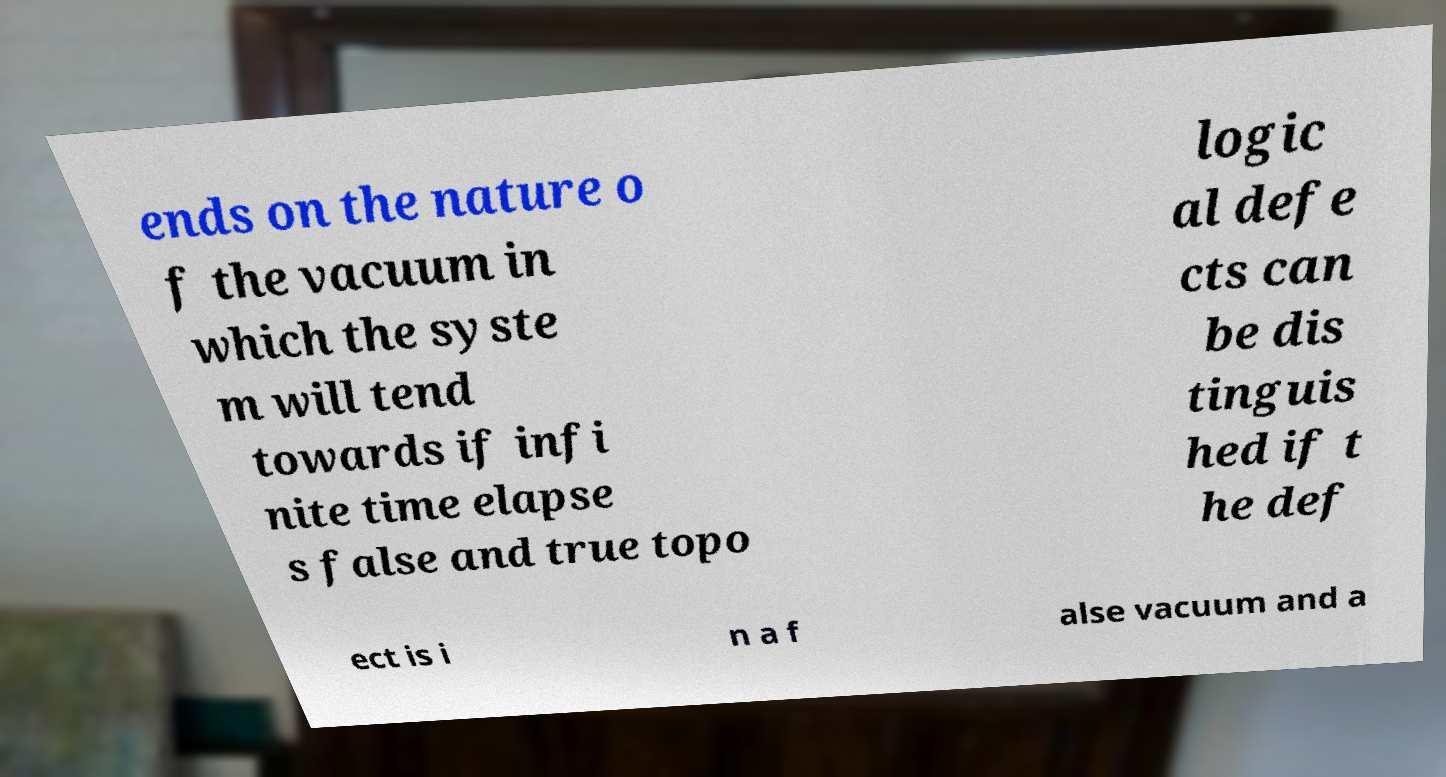Please identify and transcribe the text found in this image. ends on the nature o f the vacuum in which the syste m will tend towards if infi nite time elapse s false and true topo logic al defe cts can be dis tinguis hed if t he def ect is i n a f alse vacuum and a 